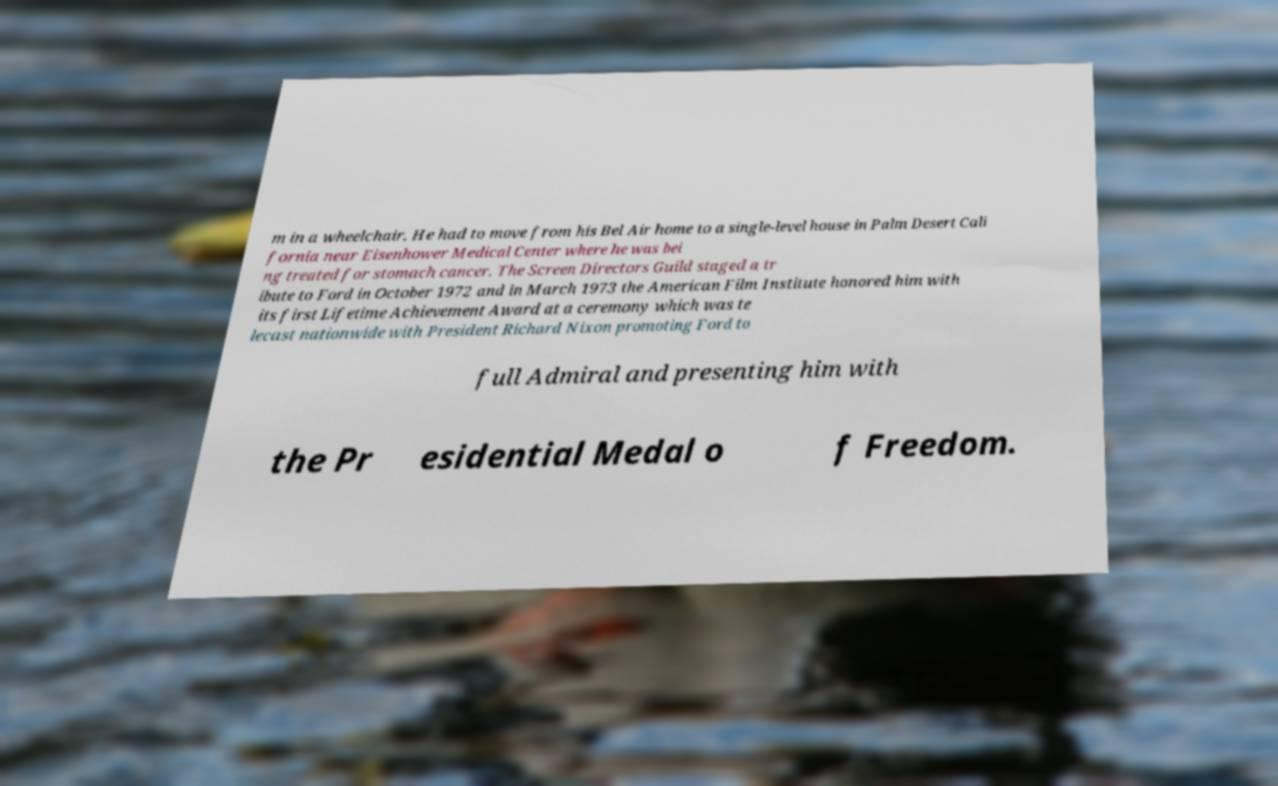Please identify and transcribe the text found in this image. m in a wheelchair. He had to move from his Bel Air home to a single-level house in Palm Desert Cali fornia near Eisenhower Medical Center where he was bei ng treated for stomach cancer. The Screen Directors Guild staged a tr ibute to Ford in October 1972 and in March 1973 the American Film Institute honored him with its first Lifetime Achievement Award at a ceremony which was te lecast nationwide with President Richard Nixon promoting Ford to full Admiral and presenting him with the Pr esidential Medal o f Freedom. 